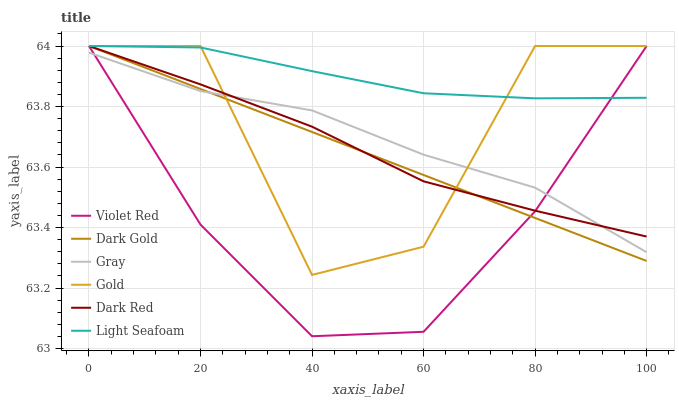Does Violet Red have the minimum area under the curve?
Answer yes or no. Yes. Does Light Seafoam have the maximum area under the curve?
Answer yes or no. Yes. Does Gold have the minimum area under the curve?
Answer yes or no. No. Does Gold have the maximum area under the curve?
Answer yes or no. No. Is Dark Gold the smoothest?
Answer yes or no. Yes. Is Gold the roughest?
Answer yes or no. Yes. Is Violet Red the smoothest?
Answer yes or no. No. Is Violet Red the roughest?
Answer yes or no. No. Does Violet Red have the lowest value?
Answer yes or no. Yes. Does Gold have the lowest value?
Answer yes or no. No. Does Light Seafoam have the highest value?
Answer yes or no. Yes. Is Gray less than Light Seafoam?
Answer yes or no. Yes. Is Light Seafoam greater than Gray?
Answer yes or no. Yes. Does Gray intersect Dark Gold?
Answer yes or no. Yes. Is Gray less than Dark Gold?
Answer yes or no. No. Is Gray greater than Dark Gold?
Answer yes or no. No. Does Gray intersect Light Seafoam?
Answer yes or no. No. 